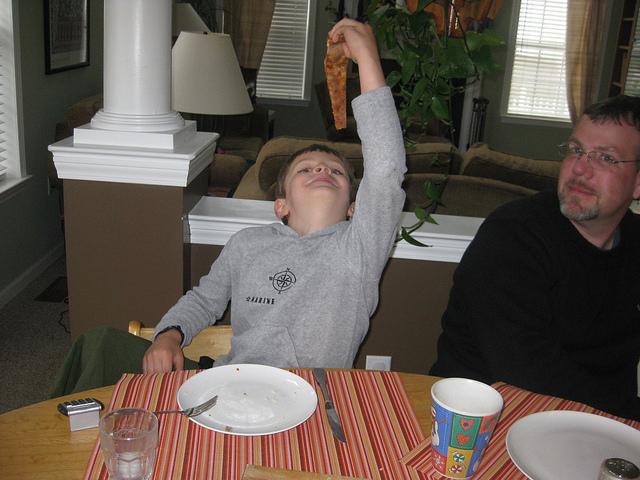What kind of plant is in the picture?
Quick response, please. Houseplant. Is this child at home?
Be succinct. Yes. What is the kid going to eat?
Be succinct. Pizza. Who is the kid looking at?
Give a very brief answer. No one. Is this indoors?
Write a very short answer. Yes. 